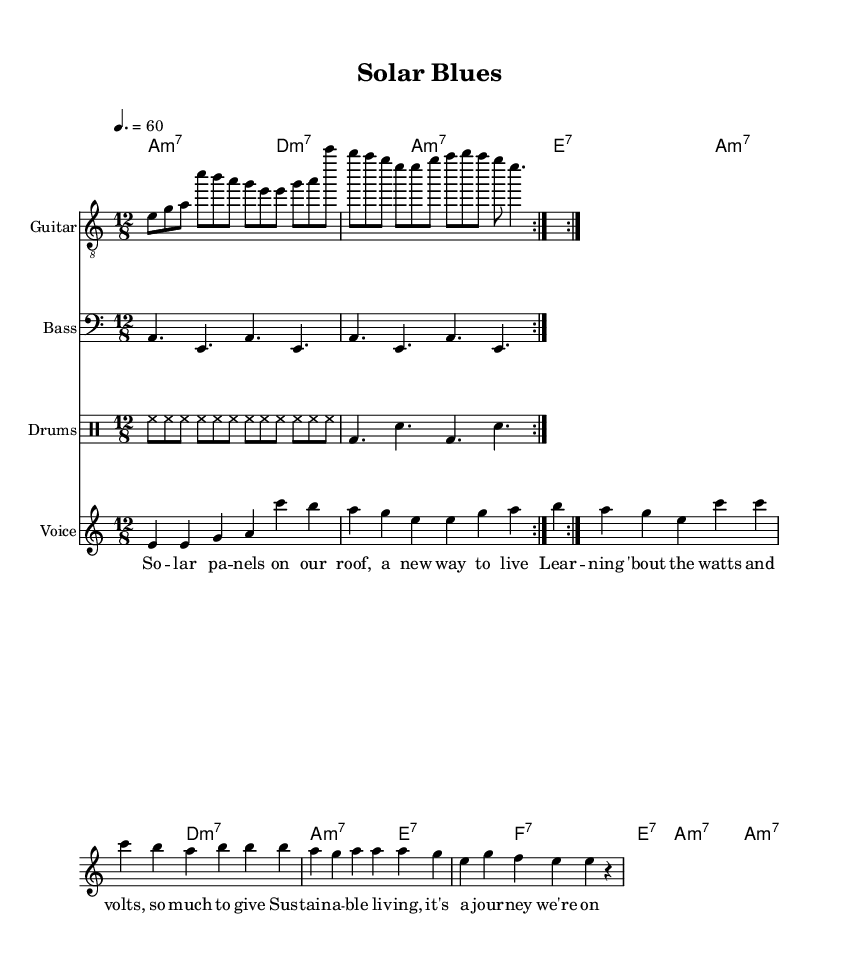What is the key signature of this music? The key signature shows that there is one flat in the key signature, indicating it is in A minor. A minor has the same key signature as C major, but it is defined as a minor key.
Answer: A minor What is the time signature of the piece? The time signature 12/8 indicates that there are 12 eighth notes in each measure, grouping them into four beats, where each beat is represented by a dotted quarter note. This is characteristic of slower, bluesy styles.
Answer: 12/8 What is the tempo marking for the music? The tempo marking is set at 60 beats per minute, indicating a slow pace suitable for the contemplative nature of the music. This tempo allows the music to have a relaxed, laid-back feel, typical of blues.
Answer: 60 How many measures are there in the guitar part? The guitar part contains a repeat sign, which indicates that the section is played twice. Counting the measures before the repeat and considering the repeat, there are 8 measures in total.
Answer: 8 What chords are being played during the verse? The chords listed in the chord names section for the verse are A minor 7, D minor 7, A minor 7, and E7, which create a typical bluesy harmonic progression that reflects the journey of learning.
Answer: A minor 7, D minor 7, E7 What musical style is represented in this piece? The piece is clearly identified as "Electric Blues" based on its chord structure, rhythm, and general feel, which embodies the characteristics of the blues genre while focusing on sustainability, making the content relevant to the theme.
Answer: Electric Blues 